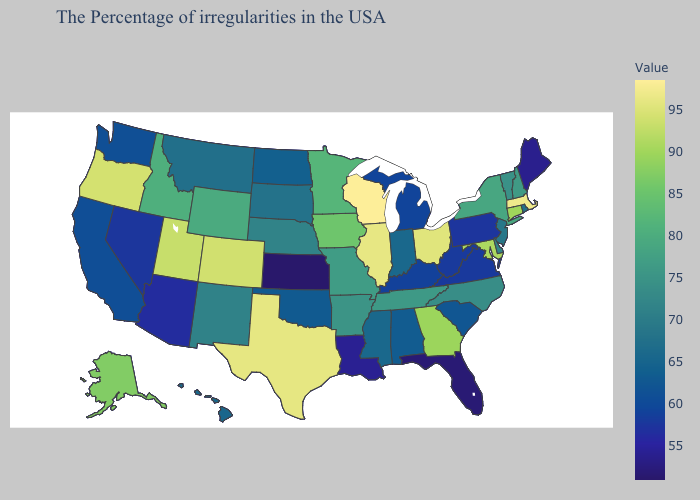Does Kentucky have the highest value in the South?
Be succinct. No. Does Oklahoma have a lower value than Illinois?
Write a very short answer. Yes. Which states have the lowest value in the West?
Concise answer only. Arizona. Which states have the highest value in the USA?
Be succinct. Wisconsin. Does Alaska have the highest value in the West?
Short answer required. No. Which states have the lowest value in the West?
Write a very short answer. Arizona. Which states have the highest value in the USA?
Keep it brief. Wisconsin. 